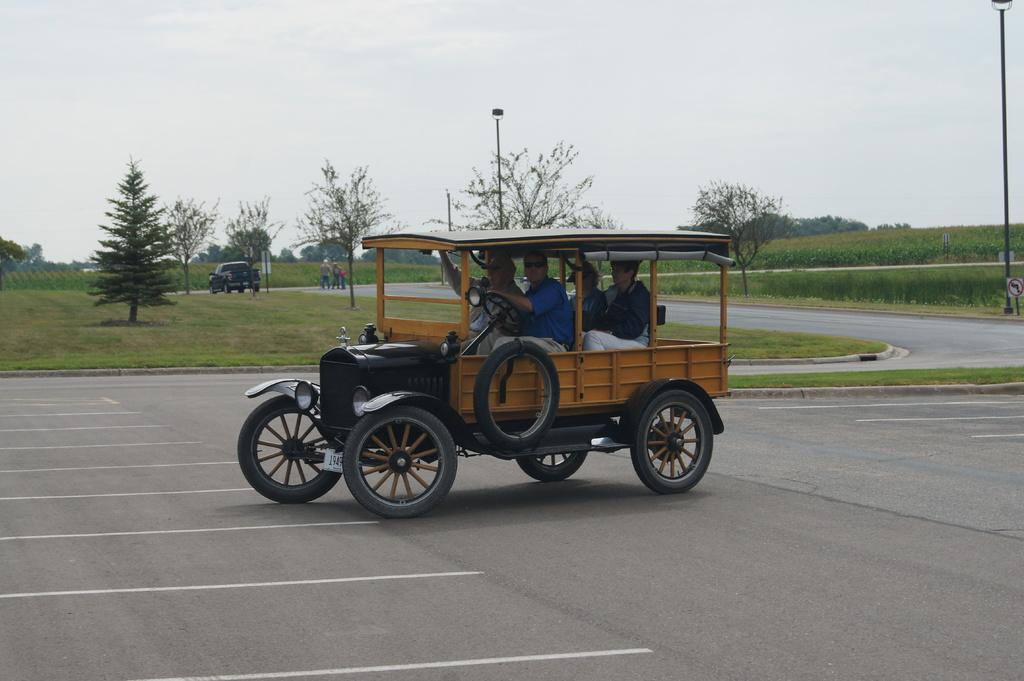Can you describe this image briefly? In the center of the image we can see a vehicle on the road and there are people sitting in the vehicle. In the background there are people walking. We can see trees, car, poles, hill and sky. 